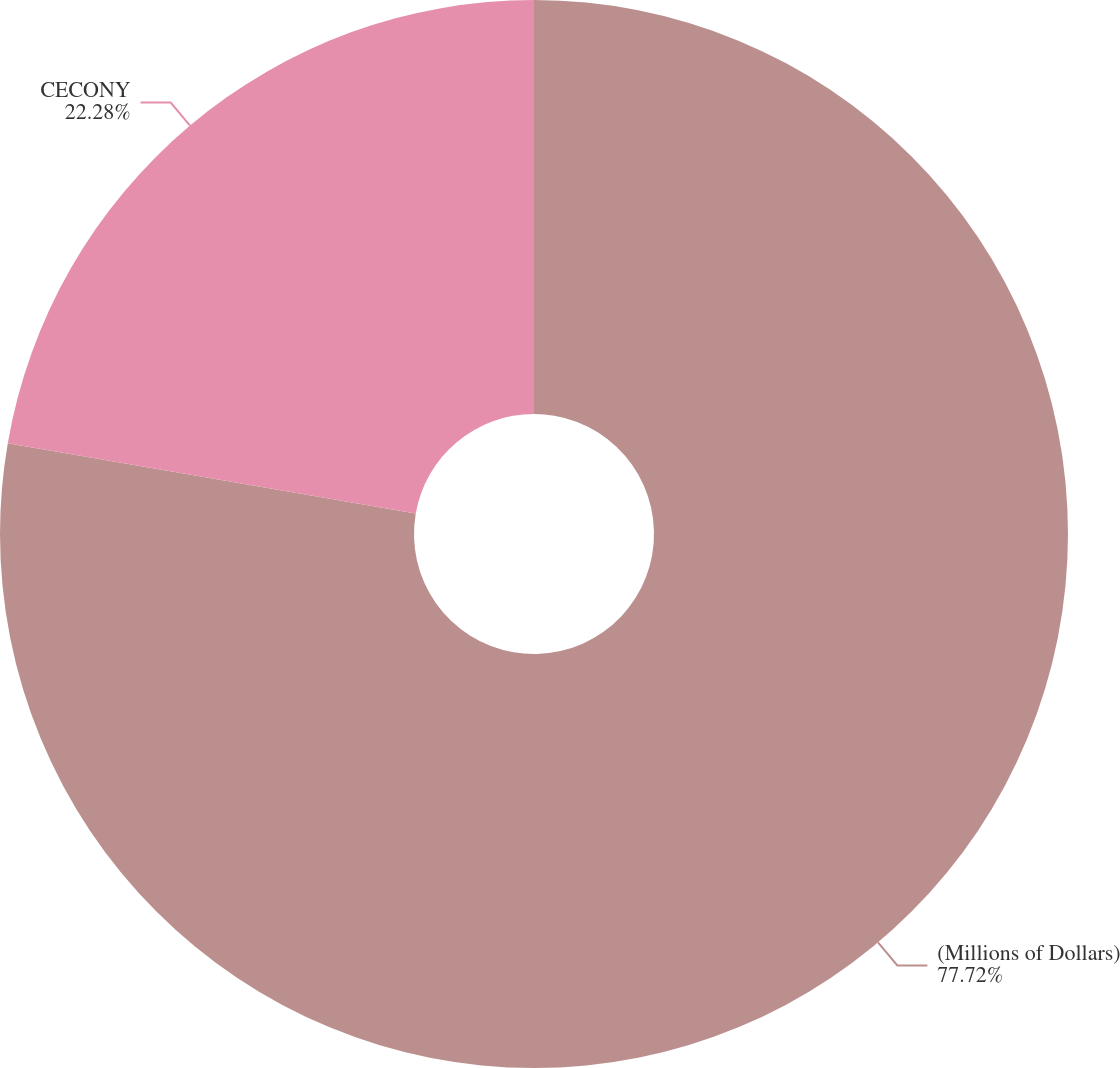<chart> <loc_0><loc_0><loc_500><loc_500><pie_chart><fcel>(Millions of Dollars)<fcel>CECONY<nl><fcel>77.72%<fcel>22.28%<nl></chart> 